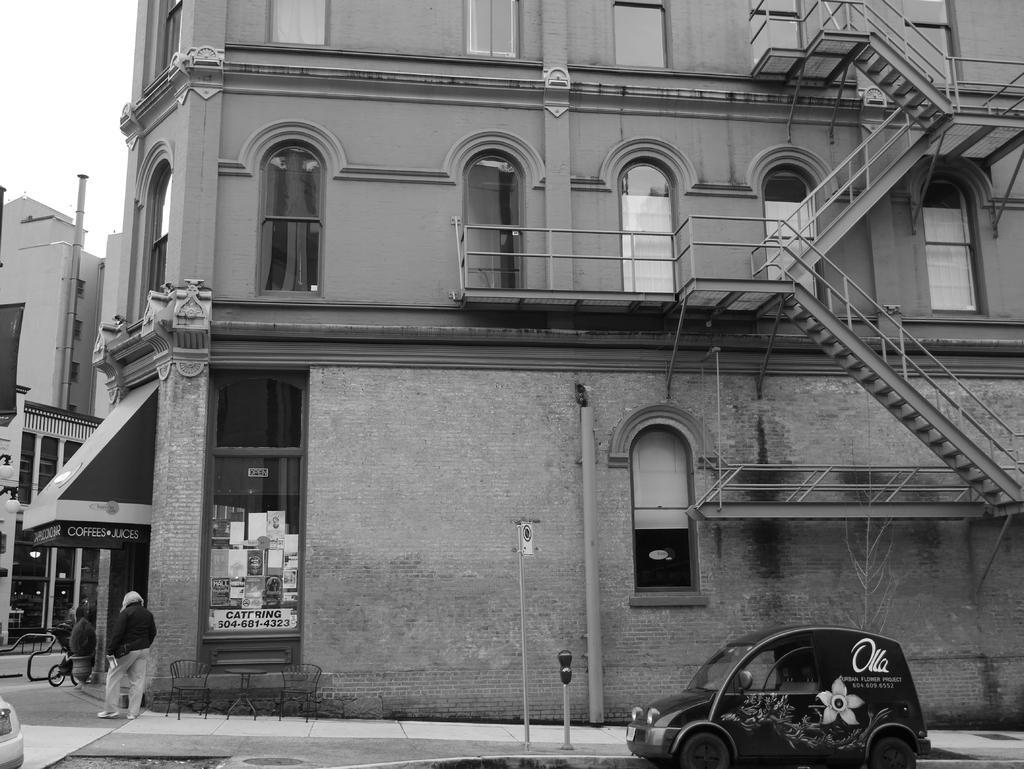Can you describe this image briefly? In this image I can see a building , on the building I can see the windows and staircase and at the bottom I can see poles , vehicle s and person visible on road 